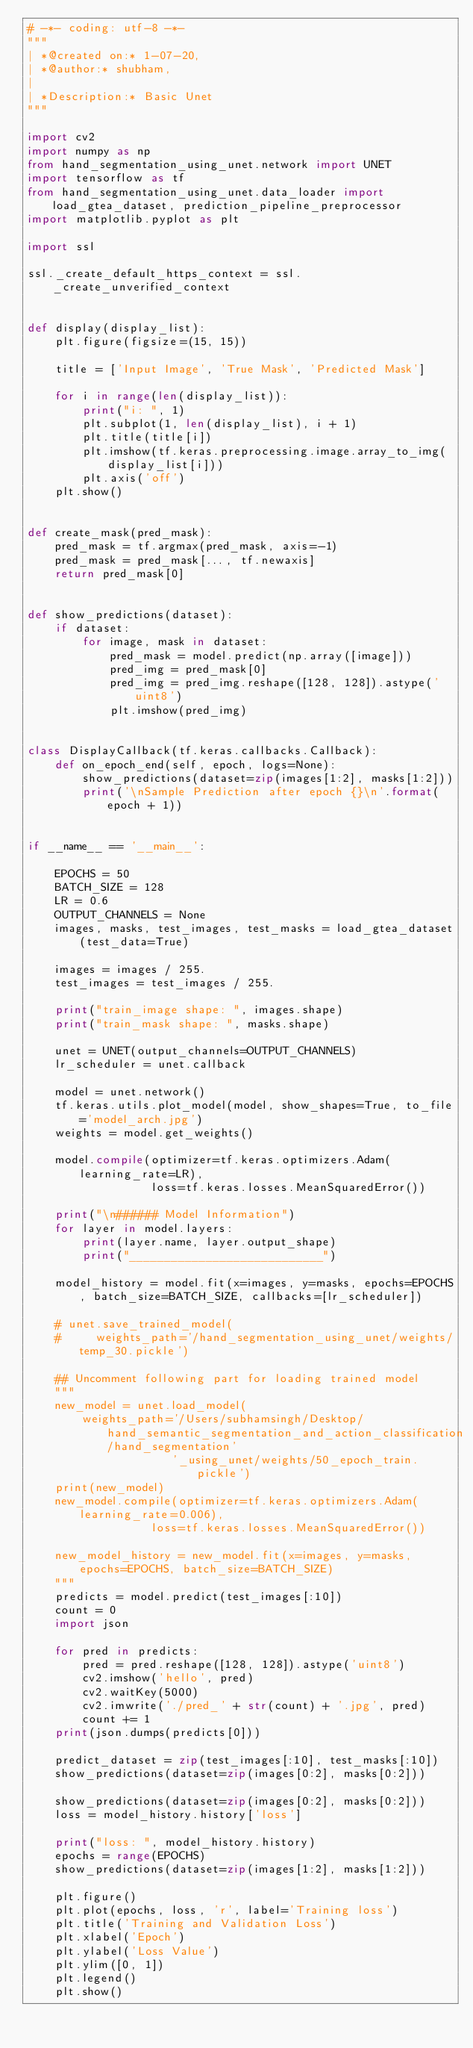<code> <loc_0><loc_0><loc_500><loc_500><_Python_># -*- coding: utf-8 -*-
"""
| *@created on:* 1-07-20,
| *@author:* shubham,
|
| *Description:* Basic Unet
"""

import cv2
import numpy as np
from hand_segmentation_using_unet.network import UNET
import tensorflow as tf
from hand_segmentation_using_unet.data_loader import load_gtea_dataset, prediction_pipeline_preprocessor
import matplotlib.pyplot as plt

import ssl

ssl._create_default_https_context = ssl._create_unverified_context


def display(display_list):
    plt.figure(figsize=(15, 15))

    title = ['Input Image', 'True Mask', 'Predicted Mask']

    for i in range(len(display_list)):
        print("i: ", 1)
        plt.subplot(1, len(display_list), i + 1)
        plt.title(title[i])
        plt.imshow(tf.keras.preprocessing.image.array_to_img(display_list[i]))
        plt.axis('off')
    plt.show()


def create_mask(pred_mask):
    pred_mask = tf.argmax(pred_mask, axis=-1)
    pred_mask = pred_mask[..., tf.newaxis]
    return pred_mask[0]


def show_predictions(dataset):
    if dataset:
        for image, mask in dataset:
            pred_mask = model.predict(np.array([image]))
            pred_img = pred_mask[0]
            pred_img = pred_img.reshape([128, 128]).astype('uint8')
            plt.imshow(pred_img)


class DisplayCallback(tf.keras.callbacks.Callback):
    def on_epoch_end(self, epoch, logs=None):
        show_predictions(dataset=zip(images[1:2], masks[1:2]))
        print('\nSample Prediction after epoch {}\n'.format(epoch + 1))


if __name__ == '__main__':

    EPOCHS = 50
    BATCH_SIZE = 128
    LR = 0.6
    OUTPUT_CHANNELS = None
    images, masks, test_images, test_masks = load_gtea_dataset(test_data=True)

    images = images / 255.
    test_images = test_images / 255.

    print("train_image shape: ", images.shape)
    print("train_mask shape: ", masks.shape)

    unet = UNET(output_channels=OUTPUT_CHANNELS)
    lr_scheduler = unet.callback

    model = unet.network()
    tf.keras.utils.plot_model(model, show_shapes=True, to_file='model_arch.jpg')
    weights = model.get_weights()

    model.compile(optimizer=tf.keras.optimizers.Adam(learning_rate=LR),
                  loss=tf.keras.losses.MeanSquaredError())

    print("\n###### Model Information")
    for layer in model.layers:
        print(layer.name, layer.output_shape)
        print("____________________________")

    model_history = model.fit(x=images, y=masks, epochs=EPOCHS, batch_size=BATCH_SIZE, callbacks=[lr_scheduler])

    # unet.save_trained_model(
    #     weights_path='/hand_segmentation_using_unet/weights/temp_30.pickle')

    ## Uncomment following part for loading trained model
    """
    new_model = unet.load_model(
        weights_path='/Users/subhamsingh/Desktop/hand_semantic_segmentation_and_action_classification/hand_segmentation'
                     '_using_unet/weights/50_epoch_train.pickle')
    print(new_model)
    new_model.compile(optimizer=tf.keras.optimizers.Adam(learning_rate=0.006),
                  loss=tf.keras.losses.MeanSquaredError())

    new_model_history = new_model.fit(x=images, y=masks, epochs=EPOCHS, batch_size=BATCH_SIZE)
    """
    predicts = model.predict(test_images[:10])
    count = 0
    import json

    for pred in predicts:
        pred = pred.reshape([128, 128]).astype('uint8')
        cv2.imshow('hello', pred)
        cv2.waitKey(5000)
        cv2.imwrite('./pred_' + str(count) + '.jpg', pred)
        count += 1
    print(json.dumps(predicts[0]))

    predict_dataset = zip(test_images[:10], test_masks[:10])
    show_predictions(dataset=zip(images[0:2], masks[0:2]))

    show_predictions(dataset=zip(images[0:2], masks[0:2]))
    loss = model_history.history['loss']

    print("loss: ", model_history.history)
    epochs = range(EPOCHS)
    show_predictions(dataset=zip(images[1:2], masks[1:2]))

    plt.figure()
    plt.plot(epochs, loss, 'r', label='Training loss')
    plt.title('Training and Validation Loss')
    plt.xlabel('Epoch')
    plt.ylabel('Loss Value')
    plt.ylim([0, 1])
    plt.legend()
    plt.show()
</code> 